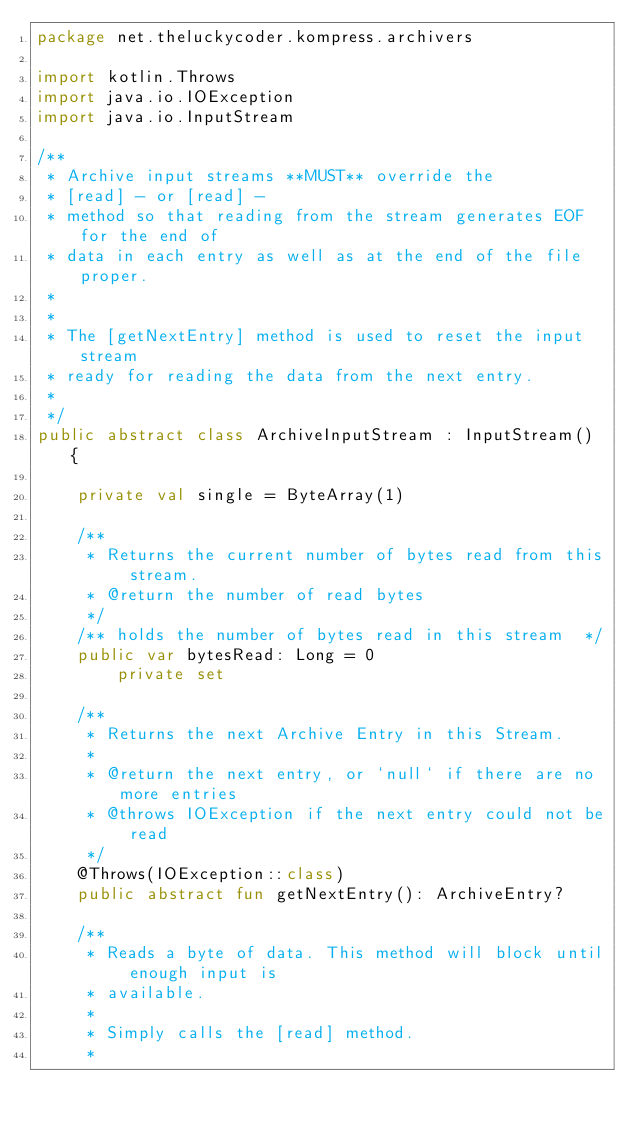Convert code to text. <code><loc_0><loc_0><loc_500><loc_500><_Kotlin_>package net.theluckycoder.kompress.archivers

import kotlin.Throws
import java.io.IOException
import java.io.InputStream

/**
 * Archive input streams **MUST** override the
 * [read] - or [read] -
 * method so that reading from the stream generates EOF for the end of
 * data in each entry as well as at the end of the file proper.
 *
 *
 * The [getNextEntry] method is used to reset the input stream
 * ready for reading the data from the next entry.
 *
 */
public abstract class ArchiveInputStream : InputStream() {

    private val single = ByteArray(1)

    /**
     * Returns the current number of bytes read from this stream.
     * @return the number of read bytes
     */
    /** holds the number of bytes read in this stream  */
    public var bytesRead: Long = 0
        private set

    /**
     * Returns the next Archive Entry in this Stream.
     *
     * @return the next entry, or `null` if there are no more entries
     * @throws IOException if the next entry could not be read
     */
    @Throws(IOException::class)
    public abstract fun getNextEntry(): ArchiveEntry?

    /**
     * Reads a byte of data. This method will block until enough input is
     * available.
     *
     * Simply calls the [read] method.
     *</code> 